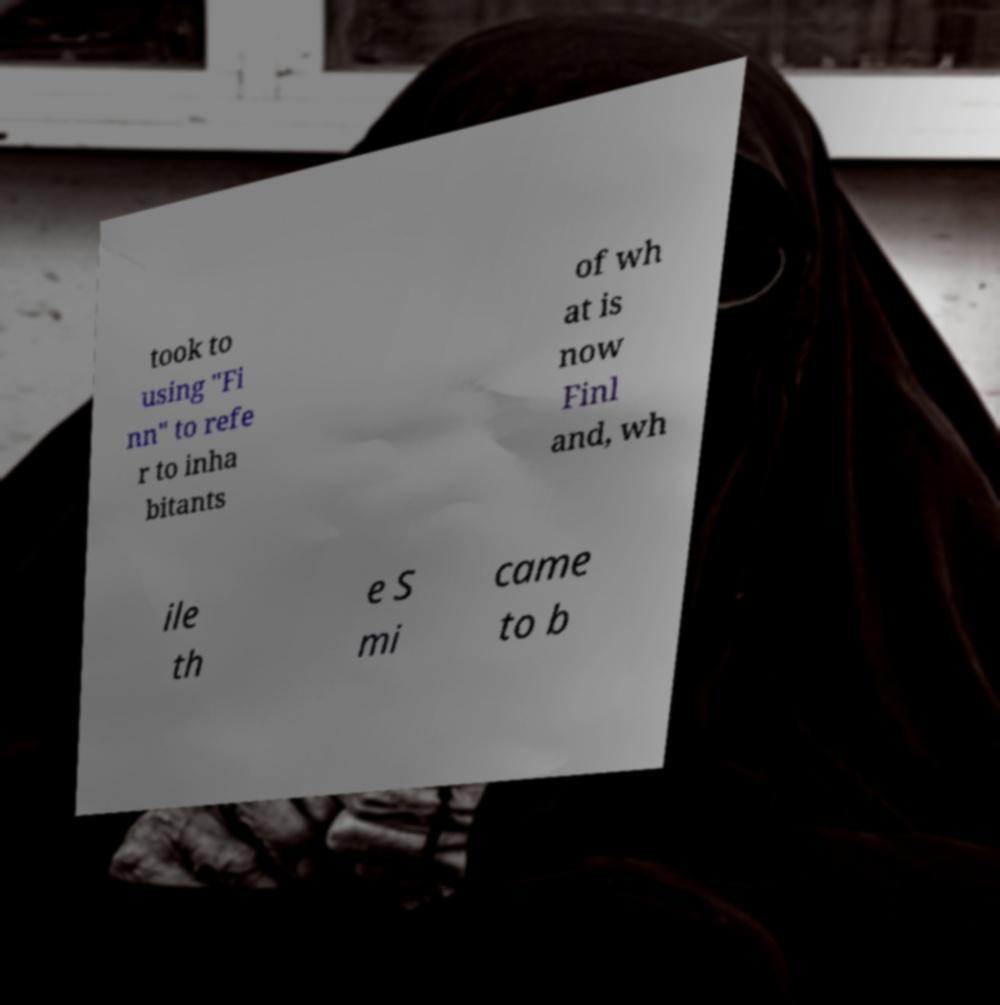There's text embedded in this image that I need extracted. Can you transcribe it verbatim? took to using "Fi nn" to refe r to inha bitants of wh at is now Finl and, wh ile th e S mi came to b 